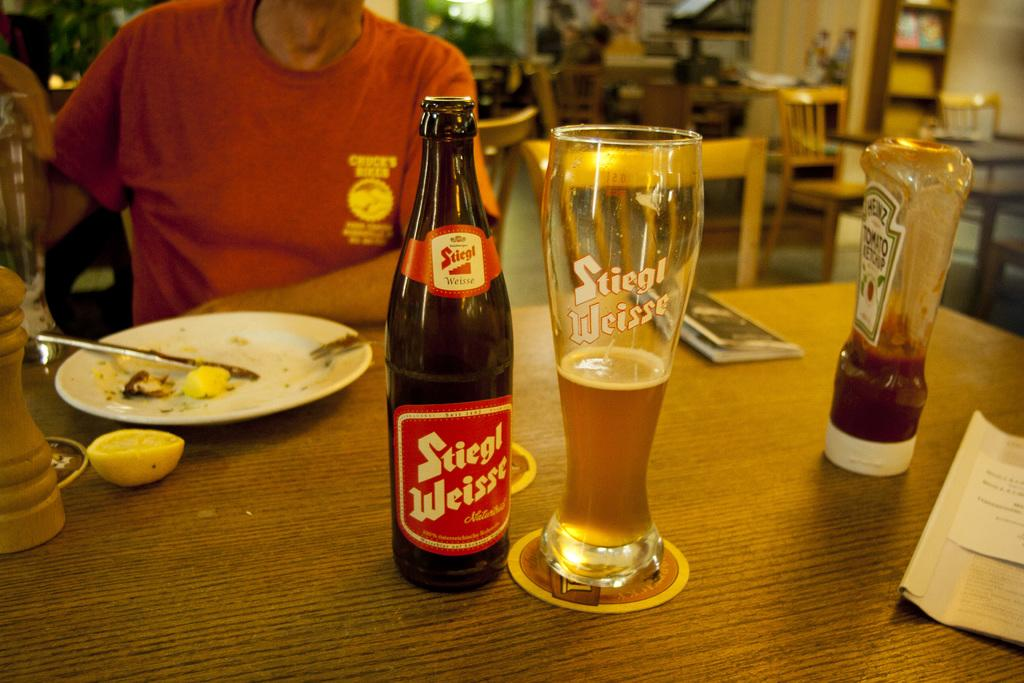<image>
Provide a brief description of the given image. A bottle with Stiegl brand is sitting next to a glass on a table. 